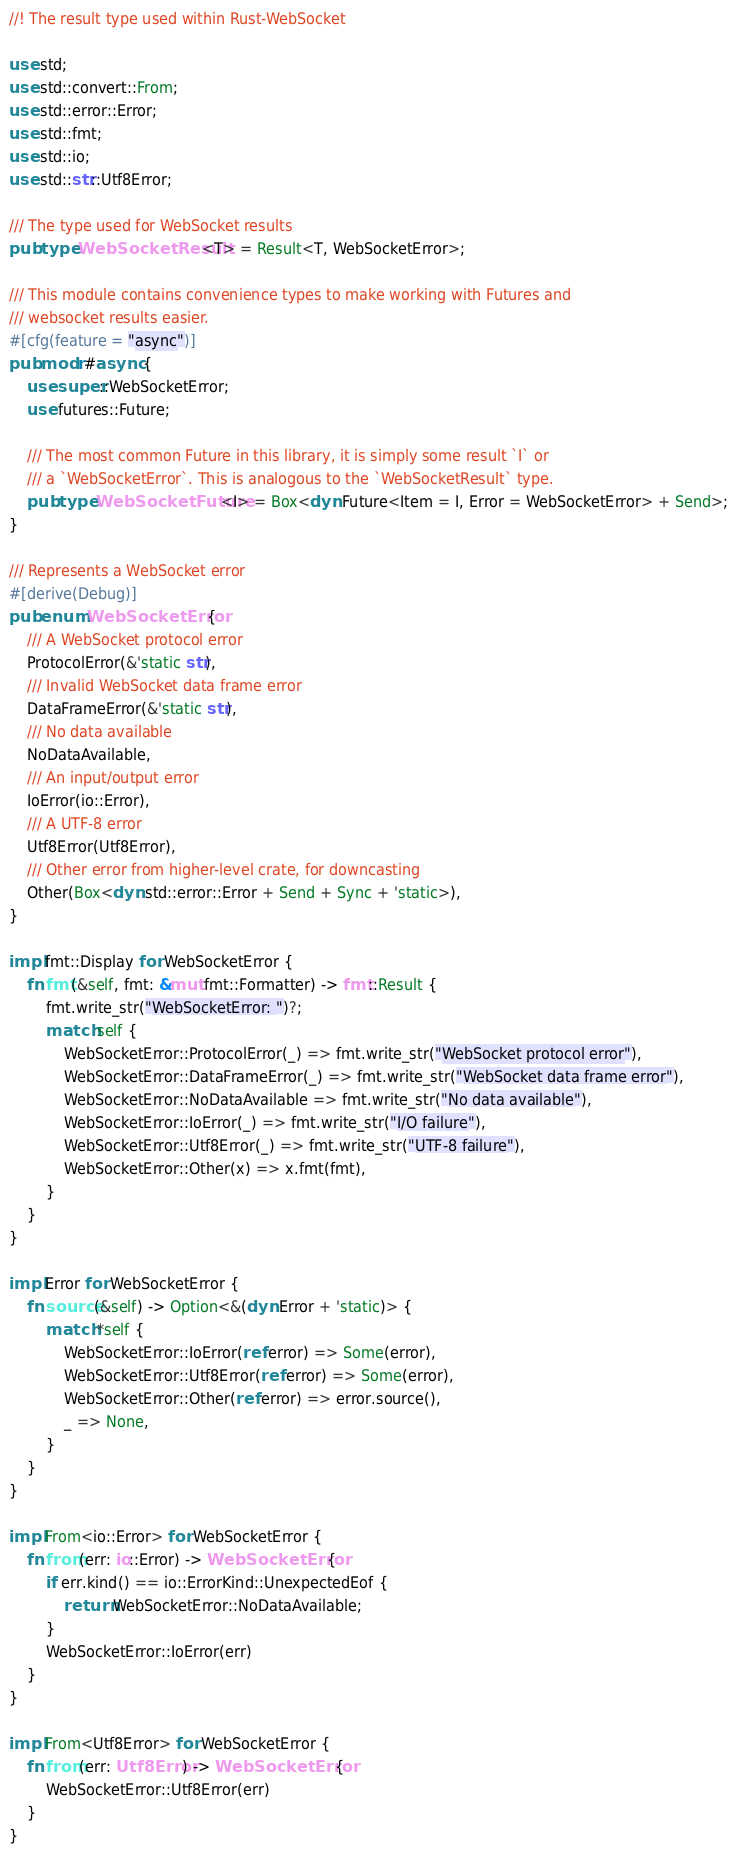<code> <loc_0><loc_0><loc_500><loc_500><_Rust_>//! The result type used within Rust-WebSocket

use std;
use std::convert::From;
use std::error::Error;
use std::fmt;
use std::io;
use std::str::Utf8Error;

/// The type used for WebSocket results
pub type WebSocketResult<T> = Result<T, WebSocketError>;

/// This module contains convenience types to make working with Futures and
/// websocket results easier.
#[cfg(feature = "async")]
pub mod r#async {
	use super::WebSocketError;
	use futures::Future;

	/// The most common Future in this library, it is simply some result `I` or
	/// a `WebSocketError`. This is analogous to the `WebSocketResult` type.
	pub type WebSocketFuture<I> = Box<dyn Future<Item = I, Error = WebSocketError> + Send>;
}

/// Represents a WebSocket error
#[derive(Debug)]
pub enum WebSocketError {
	/// A WebSocket protocol error
	ProtocolError(&'static str),
	/// Invalid WebSocket data frame error
	DataFrameError(&'static str),
	/// No data available
	NoDataAvailable,
	/// An input/output error
	IoError(io::Error),
	/// A UTF-8 error
	Utf8Error(Utf8Error),
	/// Other error from higher-level crate, for downcasting
	Other(Box<dyn std::error::Error + Send + Sync + 'static>),
}

impl fmt::Display for WebSocketError {
	fn fmt(&self, fmt: &mut fmt::Formatter) -> fmt::Result {
		fmt.write_str("WebSocketError: ")?;
		match self {
			WebSocketError::ProtocolError(_) => fmt.write_str("WebSocket protocol error"),
			WebSocketError::DataFrameError(_) => fmt.write_str("WebSocket data frame error"),
			WebSocketError::NoDataAvailable => fmt.write_str("No data available"),
			WebSocketError::IoError(_) => fmt.write_str("I/O failure"),
			WebSocketError::Utf8Error(_) => fmt.write_str("UTF-8 failure"),
			WebSocketError::Other(x) => x.fmt(fmt),
		}
	}
}

impl Error for WebSocketError {
	fn source(&self) -> Option<&(dyn Error + 'static)> {
		match *self {
			WebSocketError::IoError(ref error) => Some(error),
			WebSocketError::Utf8Error(ref error) => Some(error),
			WebSocketError::Other(ref error) => error.source(),
			_ => None,
		}
	}
}

impl From<io::Error> for WebSocketError {
	fn from(err: io::Error) -> WebSocketError {
		if err.kind() == io::ErrorKind::UnexpectedEof {
			return WebSocketError::NoDataAvailable;
		}
		WebSocketError::IoError(err)
	}
}

impl From<Utf8Error> for WebSocketError {
	fn from(err: Utf8Error) -> WebSocketError {
		WebSocketError::Utf8Error(err)
	}
}
</code> 